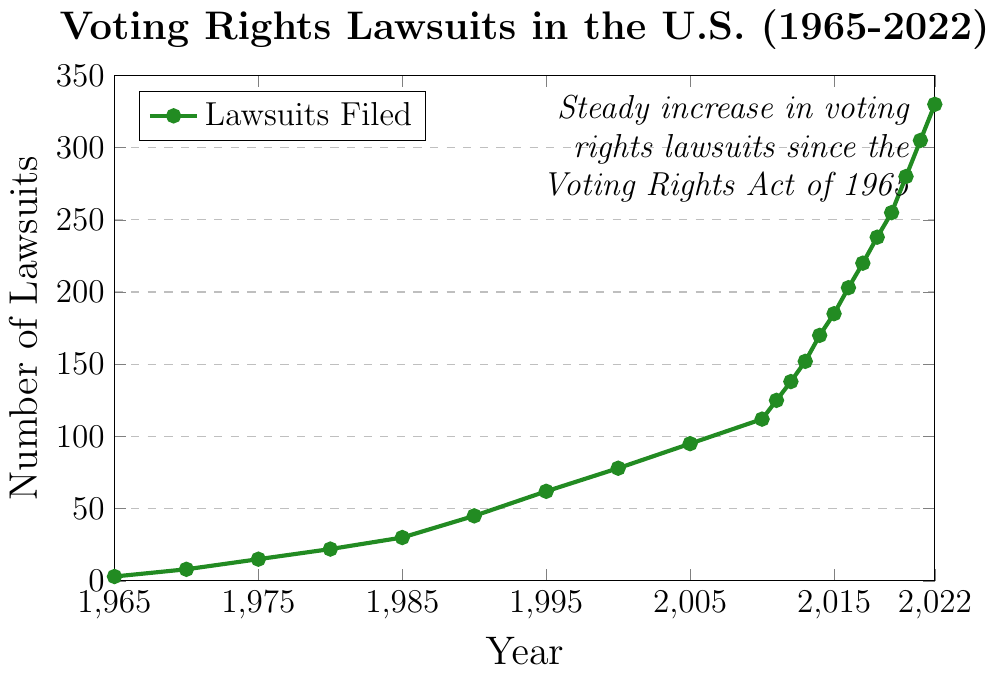What year showed the largest increase in the number of lawsuits compared to the previous year? Calculate the difference in the number of lawsuits for each year compared to the previous year and identify the year with the largest difference. The largest increase is from 2020 to 2021 (305 - 280 = 25).
Answer: 2021 How many lawsuits were filed in the year exactly halfway between 1965 and 2000? The year halfway between 1965 and 2000 is 1982.5, nearest year is 1985. In 1985, the number of lawsuits filed was 30.
Answer: 30 What is the average number of lawsuits filed per year from 1965 to 1975? The number of lawsuits in 1965, 1970, and 1975 are 3, 8, and 15 respectively. Sum them up (3 + 8 + 15 = 26) and divide by 3 to find the average (26/3 ≈ 8.67).
Answer: 8.67 In which decade did the number of lawsuits first exceed 100? Identify the years when the number of lawsuits exceed 100. It first happens in 2010. The decade is 2000-2010.
Answer: 2000-2010 By how much did the number of lawsuits increase from 1995 to 2005? Subtract the number of lawsuits in 1995 from that in 2005 (95 - 62 = 33).
Answer: 33 In which year did the number of lawsuits reach 200? Locate the closest year in the data provided where the number of lawsuits is 200 or nearest to it and above. The year is 2016 with 203 lawsuits.
Answer: 2016 What is the cumulative number of lawsuits filed from 1965 to 2022? Sum up the number of lawsuits filed for each year given in the data. (3 + 8 + 15 + 22 + 30 + 45 + 62 + 78 + 95 + 112 + 125 + 138 + 152 + 170 + 185 + 203 + 220 + 238 + 255 + 280 + 305 + 330 = 2927).
Answer: 2927 Was there any decline in the number of lawsuits from one year to the next? Review the number of lawsuits for each year sequentially. No year shows a decline in the number of lawsuits.
Answer: No What trend does the node at the top right of the plot highlight? The node indicates a “Steady increase in voting rights lawsuits since the Voting Rights Act of 1965."
Answer: Steady increase 